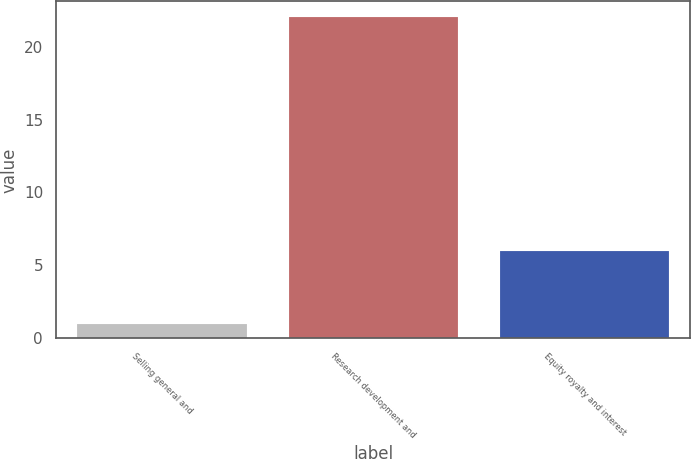Convert chart. <chart><loc_0><loc_0><loc_500><loc_500><bar_chart><fcel>Selling general and<fcel>Research development and<fcel>Equity royalty and interest<nl><fcel>1<fcel>22<fcel>6<nl></chart> 